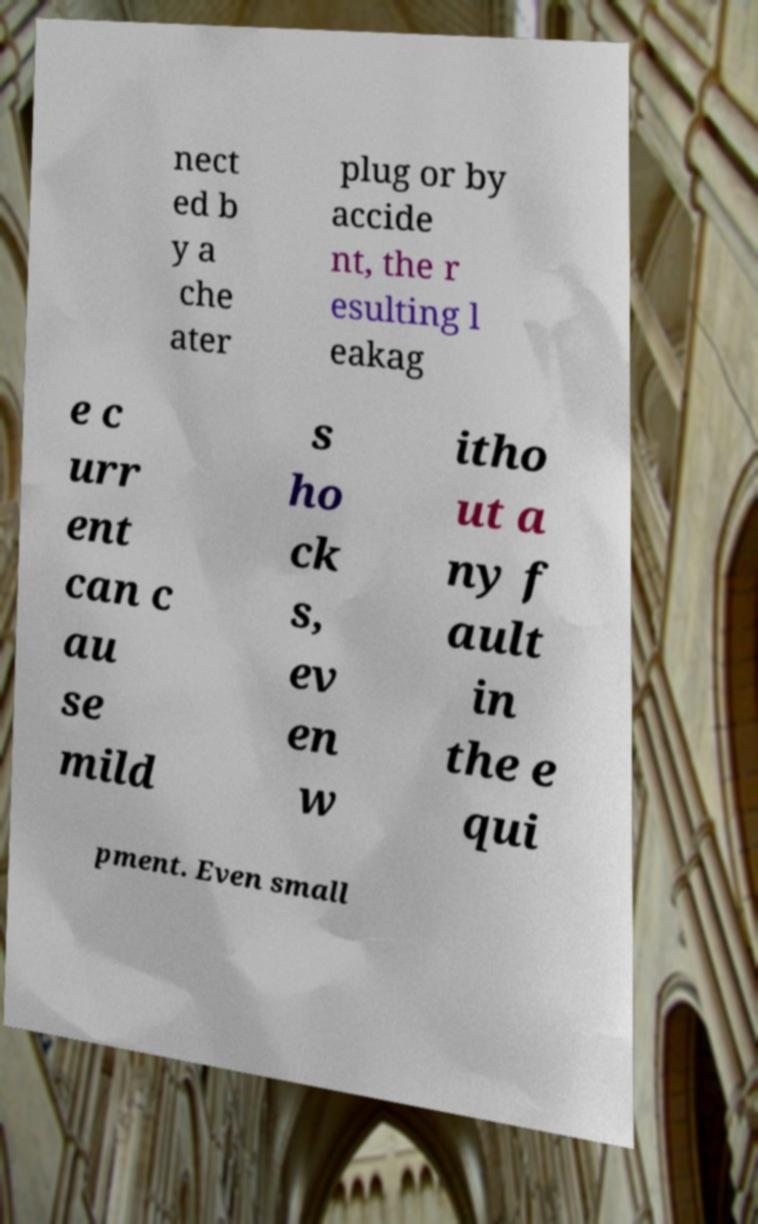There's text embedded in this image that I need extracted. Can you transcribe it verbatim? nect ed b y a che ater plug or by accide nt, the r esulting l eakag e c urr ent can c au se mild s ho ck s, ev en w itho ut a ny f ault in the e qui pment. Even small 